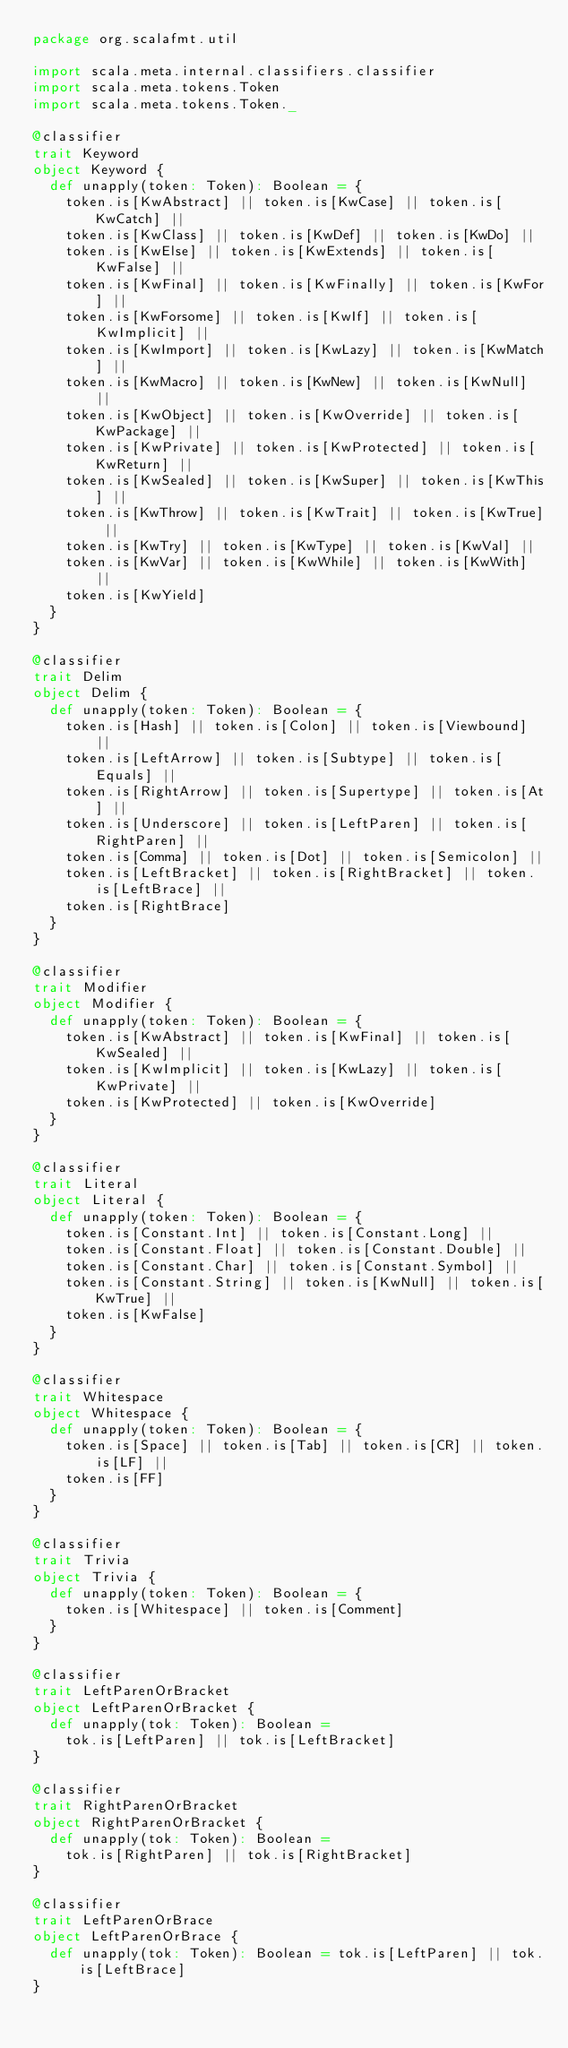Convert code to text. <code><loc_0><loc_0><loc_500><loc_500><_Scala_>package org.scalafmt.util

import scala.meta.internal.classifiers.classifier
import scala.meta.tokens.Token
import scala.meta.tokens.Token._

@classifier
trait Keyword
object Keyword {
  def unapply(token: Token): Boolean = {
    token.is[KwAbstract] || token.is[KwCase] || token.is[KwCatch] ||
    token.is[KwClass] || token.is[KwDef] || token.is[KwDo] ||
    token.is[KwElse] || token.is[KwExtends] || token.is[KwFalse] ||
    token.is[KwFinal] || token.is[KwFinally] || token.is[KwFor] ||
    token.is[KwForsome] || token.is[KwIf] || token.is[KwImplicit] ||
    token.is[KwImport] || token.is[KwLazy] || token.is[KwMatch] ||
    token.is[KwMacro] || token.is[KwNew] || token.is[KwNull] ||
    token.is[KwObject] || token.is[KwOverride] || token.is[KwPackage] ||
    token.is[KwPrivate] || token.is[KwProtected] || token.is[KwReturn] ||
    token.is[KwSealed] || token.is[KwSuper] || token.is[KwThis] ||
    token.is[KwThrow] || token.is[KwTrait] || token.is[KwTrue] ||
    token.is[KwTry] || token.is[KwType] || token.is[KwVal] ||
    token.is[KwVar] || token.is[KwWhile] || token.is[KwWith] ||
    token.is[KwYield]
  }
}

@classifier
trait Delim
object Delim {
  def unapply(token: Token): Boolean = {
    token.is[Hash] || token.is[Colon] || token.is[Viewbound] ||
    token.is[LeftArrow] || token.is[Subtype] || token.is[Equals] ||
    token.is[RightArrow] || token.is[Supertype] || token.is[At] ||
    token.is[Underscore] || token.is[LeftParen] || token.is[RightParen] ||
    token.is[Comma] || token.is[Dot] || token.is[Semicolon] ||
    token.is[LeftBracket] || token.is[RightBracket] || token.is[LeftBrace] ||
    token.is[RightBrace]
  }
}

@classifier
trait Modifier
object Modifier {
  def unapply(token: Token): Boolean = {
    token.is[KwAbstract] || token.is[KwFinal] || token.is[KwSealed] ||
    token.is[KwImplicit] || token.is[KwLazy] || token.is[KwPrivate] ||
    token.is[KwProtected] || token.is[KwOverride]
  }
}

@classifier
trait Literal
object Literal {
  def unapply(token: Token): Boolean = {
    token.is[Constant.Int] || token.is[Constant.Long] ||
    token.is[Constant.Float] || token.is[Constant.Double] ||
    token.is[Constant.Char] || token.is[Constant.Symbol] ||
    token.is[Constant.String] || token.is[KwNull] || token.is[KwTrue] ||
    token.is[KwFalse]
  }
}

@classifier
trait Whitespace
object Whitespace {
  def unapply(token: Token): Boolean = {
    token.is[Space] || token.is[Tab] || token.is[CR] || token.is[LF] ||
    token.is[FF]
  }
}

@classifier
trait Trivia
object Trivia {
  def unapply(token: Token): Boolean = {
    token.is[Whitespace] || token.is[Comment]
  }
}

@classifier
trait LeftParenOrBracket
object LeftParenOrBracket {
  def unapply(tok: Token): Boolean =
    tok.is[LeftParen] || tok.is[LeftBracket]
}

@classifier
trait RightParenOrBracket
object RightParenOrBracket {
  def unapply(tok: Token): Boolean =
    tok.is[RightParen] || tok.is[RightBracket]
}

@classifier
trait LeftParenOrBrace
object LeftParenOrBrace {
  def unapply(tok: Token): Boolean = tok.is[LeftParen] || tok.is[LeftBrace]
}
</code> 